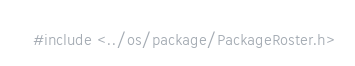Convert code to text. <code><loc_0><loc_0><loc_500><loc_500><_C_>#include <../os/package/PackageRoster.h>
</code> 